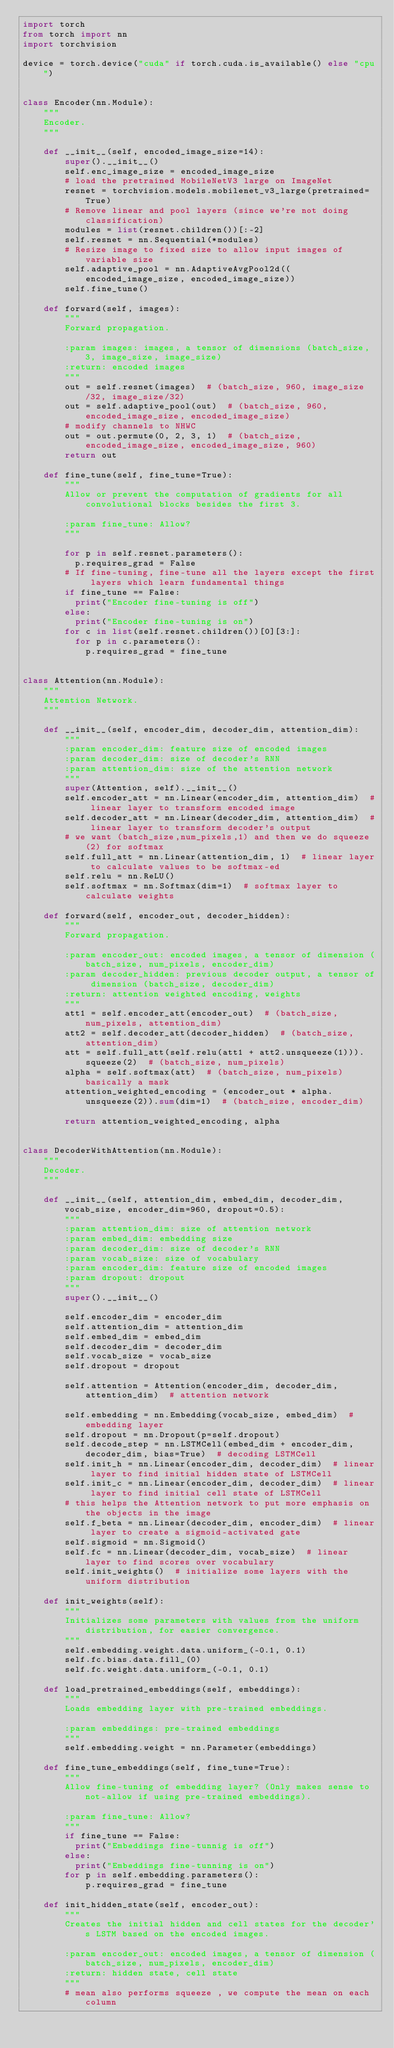<code> <loc_0><loc_0><loc_500><loc_500><_Python_>import torch
from torch import nn
import torchvision

device = torch.device("cuda" if torch.cuda.is_available() else "cpu")


class Encoder(nn.Module):
    """
    Encoder.
    """

    def __init__(self, encoded_image_size=14):
        super().__init__()
        self.enc_image_size = encoded_image_size
        # load the pretrained MobileNetV3 large on ImageNet
        resnet = torchvision.models.mobilenet_v3_large(pretrained=True)
        # Remove linear and pool layers (since we're not doing classification)
        modules = list(resnet.children())[:-2]
        self.resnet = nn.Sequential(*modules)
        # Resize image to fixed size to allow input images of variable size
        self.adaptive_pool = nn.AdaptiveAvgPool2d((encoded_image_size, encoded_image_size))
        self.fine_tune()

    def forward(self, images):
        """
        Forward propagation.

        :param images: images, a tensor of dimensions (batch_size, 3, image_size, image_size)
        :return: encoded images
        """
        out = self.resnet(images)  # (batch_size, 960, image_size/32, image_size/32)
        out = self.adaptive_pool(out)  # (batch_size, 960, encoded_image_size, encoded_image_size)
        # modify channels to NHWC
        out = out.permute(0, 2, 3, 1)  # (batch_size, encoded_image_size, encoded_image_size, 960)
        return out

    def fine_tune(self, fine_tune=True):
        """
        Allow or prevent the computation of gradients for all convolutional blocks besides the first 3.

        :param fine_tune: Allow?
        """

        for p in self.resnet.parameters():
          p.requires_grad = False
        # If fine-tuning, fine-tune all the layers except the first layers which learn fundamental things
        if fine_tune == False:
          print("Encoder fine-tuning is off")
        else:
          print("Encoder fine-tuning is on")
        for c in list(self.resnet.children())[0][3:]:
          for p in c.parameters():
            p.requires_grad = fine_tune


class Attention(nn.Module):
    """
    Attention Network.
    """

    def __init__(self, encoder_dim, decoder_dim, attention_dim):
        """
        :param encoder_dim: feature size of encoded images
        :param decoder_dim: size of decoder's RNN
        :param attention_dim: size of the attention network
        """
        super(Attention, self).__init__()
        self.encoder_att = nn.Linear(encoder_dim, attention_dim)  # linear layer to transform encoded image
        self.decoder_att = nn.Linear(decoder_dim, attention_dim)  # linear layer to transform decoder's output
        # we want (batch_size,num_pixels,1) and then we do squeeze(2) for softmax
        self.full_att = nn.Linear(attention_dim, 1)  # linear layer to calculate values to be softmax-ed
        self.relu = nn.ReLU()
        self.softmax = nn.Softmax(dim=1)  # softmax layer to calculate weights

    def forward(self, encoder_out, decoder_hidden):
        """
        Forward propagation.

        :param encoder_out: encoded images, a tensor of dimension (batch_size, num_pixels, encoder_dim)
        :param decoder_hidden: previous decoder output, a tensor of dimension (batch_size, decoder_dim)
        :return: attention weighted encoding, weights
        """
        att1 = self.encoder_att(encoder_out)  # (batch_size, num_pixels, attention_dim)
        att2 = self.decoder_att(decoder_hidden)  # (batch_size, attention_dim)
        att = self.full_att(self.relu(att1 + att2.unsqueeze(1))).squeeze(2)  # (batch_size, num_pixels)
        alpha = self.softmax(att)  # (batch_size, num_pixels) basically a mask
        attention_weighted_encoding = (encoder_out * alpha.unsqueeze(2)).sum(dim=1)  # (batch_size, encoder_dim)

        return attention_weighted_encoding, alpha


class DecoderWithAttention(nn.Module):
    """
    Decoder.
    """

    def __init__(self, attention_dim, embed_dim, decoder_dim, vocab_size, encoder_dim=960, dropout=0.5):
        """
        :param attention_dim: size of attention network
        :param embed_dim: embedding size
        :param decoder_dim: size of decoder's RNN
        :param vocab_size: size of vocabulary
        :param encoder_dim: feature size of encoded images
        :param dropout: dropout
        """
        super().__init__()

        self.encoder_dim = encoder_dim
        self.attention_dim = attention_dim
        self.embed_dim = embed_dim
        self.decoder_dim = decoder_dim
        self.vocab_size = vocab_size
        self.dropout = dropout

        self.attention = Attention(encoder_dim, decoder_dim, attention_dim)  # attention network

        self.embedding = nn.Embedding(vocab_size, embed_dim)  # embedding layer
        self.dropout = nn.Dropout(p=self.dropout)
        self.decode_step = nn.LSTMCell(embed_dim + encoder_dim, decoder_dim, bias=True)  # decoding LSTMCell
        self.init_h = nn.Linear(encoder_dim, decoder_dim)  # linear layer to find initial hidden state of LSTMCell
        self.init_c = nn.Linear(encoder_dim, decoder_dim)  # linear layer to find initial cell state of LSTMCell
        # this helps the Attention network to put more emphasis on the objects in the image
        self.f_beta = nn.Linear(decoder_dim, encoder_dim)  # linear layer to create a sigmoid-activated gate
        self.sigmoid = nn.Sigmoid()
        self.fc = nn.Linear(decoder_dim, vocab_size)  # linear layer to find scores over vocabulary
        self.init_weights()  # initialize some layers with the uniform distribution

    def init_weights(self):
        """
        Initializes some parameters with values from the uniform distribution, for easier convergence.
        """
        self.embedding.weight.data.uniform_(-0.1, 0.1)
        self.fc.bias.data.fill_(0)
        self.fc.weight.data.uniform_(-0.1, 0.1)

    def load_pretrained_embeddings(self, embeddings):
        """
        Loads embedding layer with pre-trained embeddings.

        :param embeddings: pre-trained embeddings
        """
        self.embedding.weight = nn.Parameter(embeddings)

    def fine_tune_embeddings(self, fine_tune=True):
        """
        Allow fine-tuning of embedding layer? (Only makes sense to not-allow if using pre-trained embeddings).

        :param fine_tune: Allow?
        """
        if fine_tune == False:
          print("Embeddings fine-tunnig is off")
        else:
          print("Embeddings fine-tunning is on")
        for p in self.embedding.parameters():
            p.requires_grad = fine_tune

    def init_hidden_state(self, encoder_out):
        """
        Creates the initial hidden and cell states for the decoder's LSTM based on the encoded images.

        :param encoder_out: encoded images, a tensor of dimension (batch_size, num_pixels, encoder_dim)
        :return: hidden state, cell state
        """
        # mean also performs squeeze , we compute the mean on each column</code> 